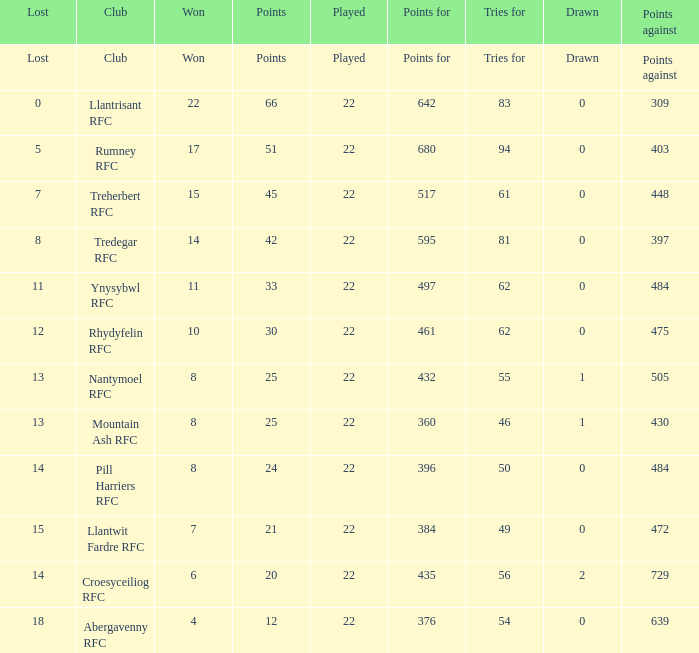Which club lost exactly 7 matches? Treherbert RFC. 